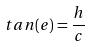<formula> <loc_0><loc_0><loc_500><loc_500>t a n ( e ) = \frac { h } { c }</formula> 